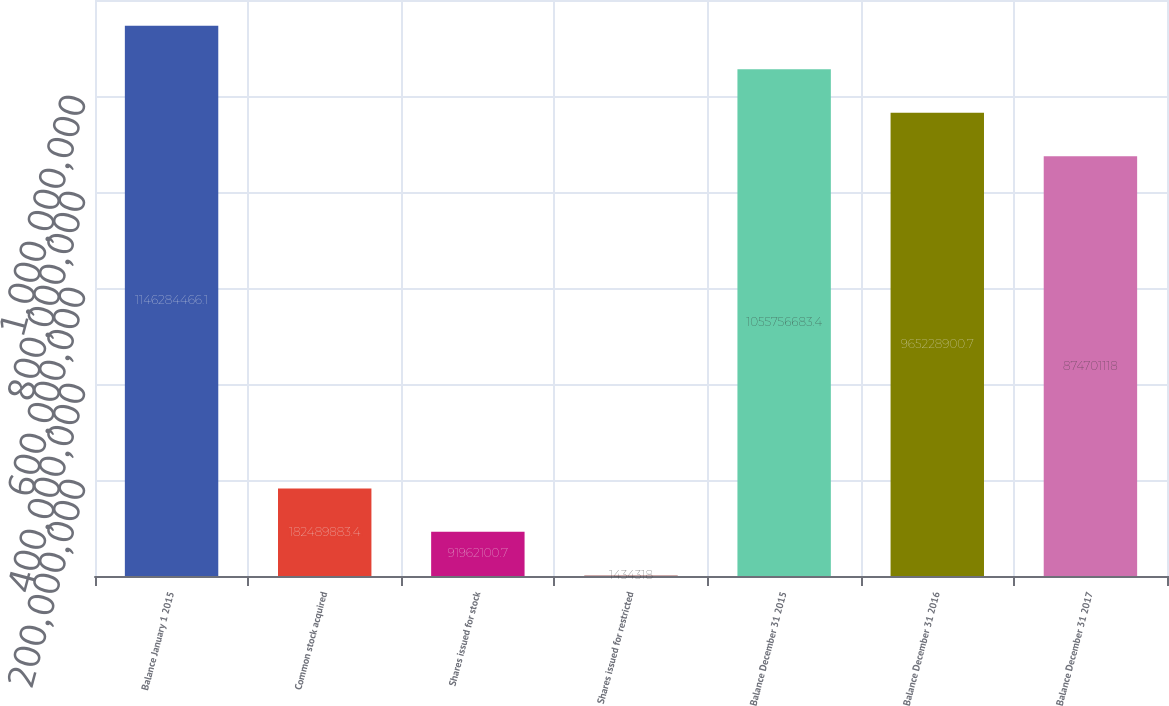<chart> <loc_0><loc_0><loc_500><loc_500><bar_chart><fcel>Balance January 1 2015<fcel>Common stock acquired<fcel>Shares issued for stock<fcel>Shares issued for restricted<fcel>Balance December 31 2015<fcel>Balance December 31 2016<fcel>Balance December 31 2017<nl><fcel>1.14628e+09<fcel>1.8249e+08<fcel>9.19621e+07<fcel>1.43432e+06<fcel>1.05576e+09<fcel>9.65229e+08<fcel>8.74701e+08<nl></chart> 